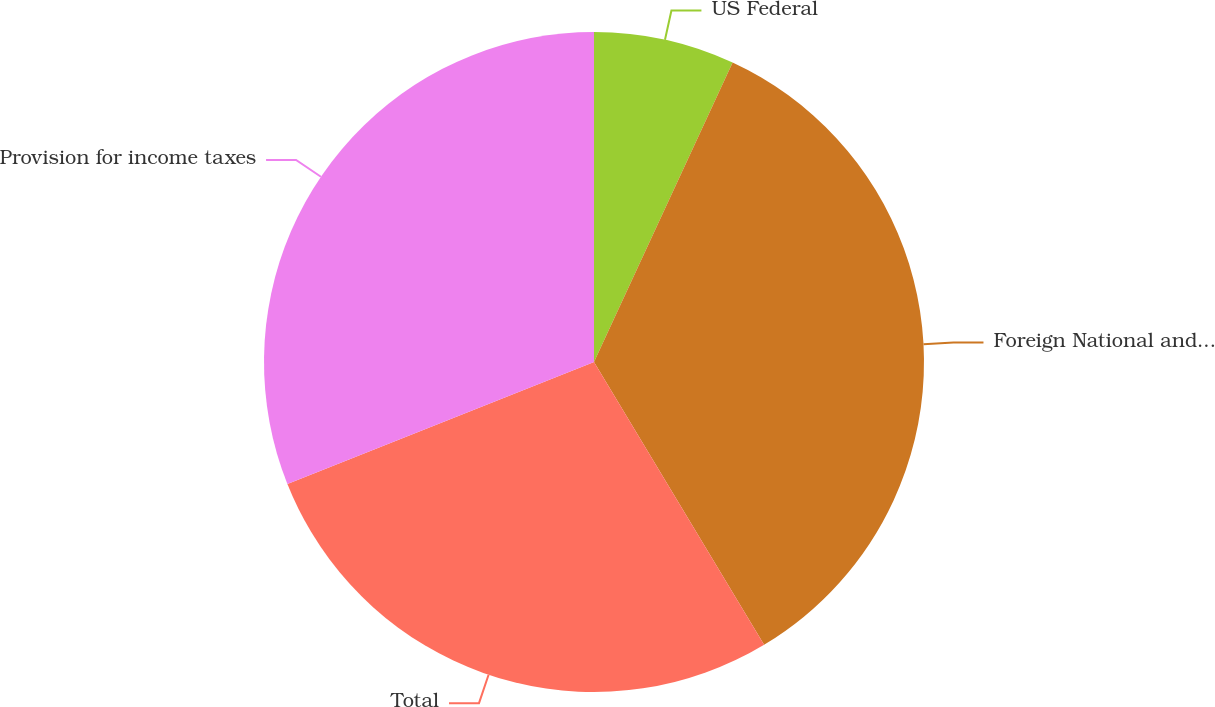Convert chart to OTSL. <chart><loc_0><loc_0><loc_500><loc_500><pie_chart><fcel>US Federal<fcel>Foreign National and Local<fcel>Total<fcel>Provision for income taxes<nl><fcel>6.9%<fcel>34.48%<fcel>27.59%<fcel>31.03%<nl></chart> 